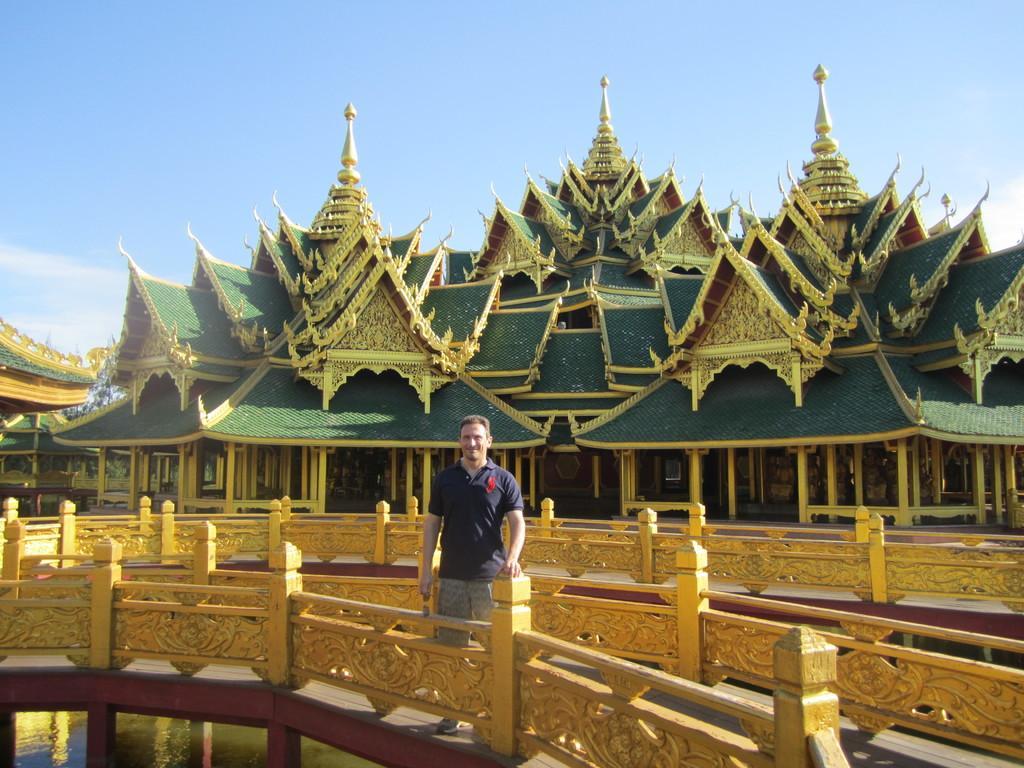Could you give a brief overview of what you see in this image? In this picture there is a man wearing blue color t-shirt is standing on the golden bridge, smiling and giving a pose. Behind there is a green and golden Buddha temples. On the top there is a blue sky. 